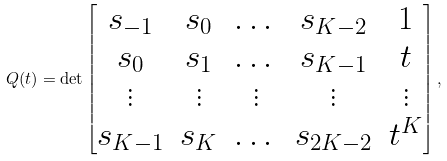<formula> <loc_0><loc_0><loc_500><loc_500>Q ( t ) = \det \begin{bmatrix} s _ { - 1 } & s _ { 0 } & \dots & s _ { K - 2 } & 1 \\ s _ { 0 } & s _ { 1 } & \dots & s _ { K - 1 } & t \\ \vdots & \vdots & \vdots & \vdots & \vdots \\ s _ { K - 1 } & s _ { K } & \dots & s _ { 2 K - 2 } & t ^ { K } \end{bmatrix} ,</formula> 